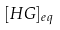<formula> <loc_0><loc_0><loc_500><loc_500>[ H G ] _ { e q }</formula> 